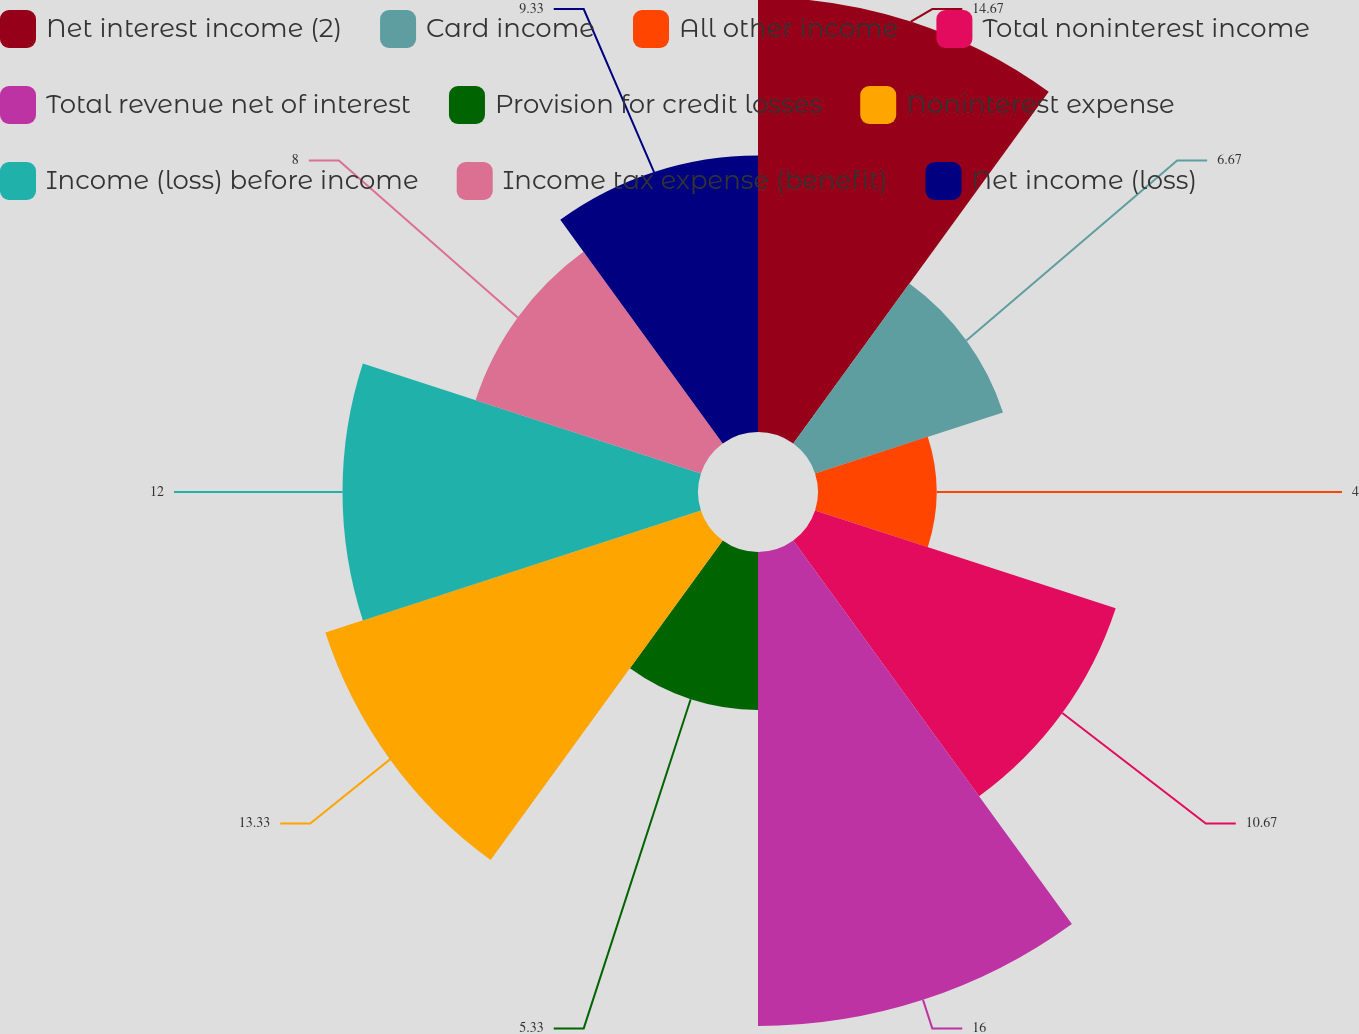Convert chart. <chart><loc_0><loc_0><loc_500><loc_500><pie_chart><fcel>Net interest income (2)<fcel>Card income<fcel>All other income<fcel>Total noninterest income<fcel>Total revenue net of interest<fcel>Provision for credit losses<fcel>Noninterest expense<fcel>Income (loss) before income<fcel>Income tax expense (benefit)<fcel>Net income (loss)<nl><fcel>14.67%<fcel>6.67%<fcel>4.0%<fcel>10.67%<fcel>16.0%<fcel>5.33%<fcel>13.33%<fcel>12.0%<fcel>8.0%<fcel>9.33%<nl></chart> 